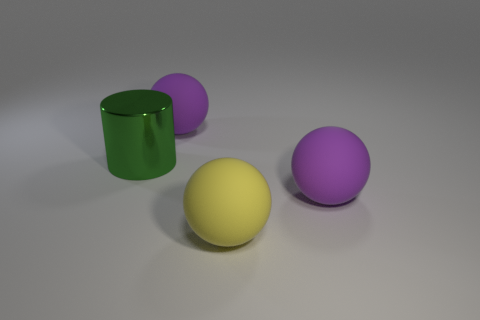What is the shape of the metal thing? The object in the picture appears to be a cylindrical shape, similar to a can or a tube. Specifically, it's a 3D geometric figure with two identical flat ends that are circular in shape and a curved side connecting them. This type of shape is often associated with items like pipes, drums, or containers. 